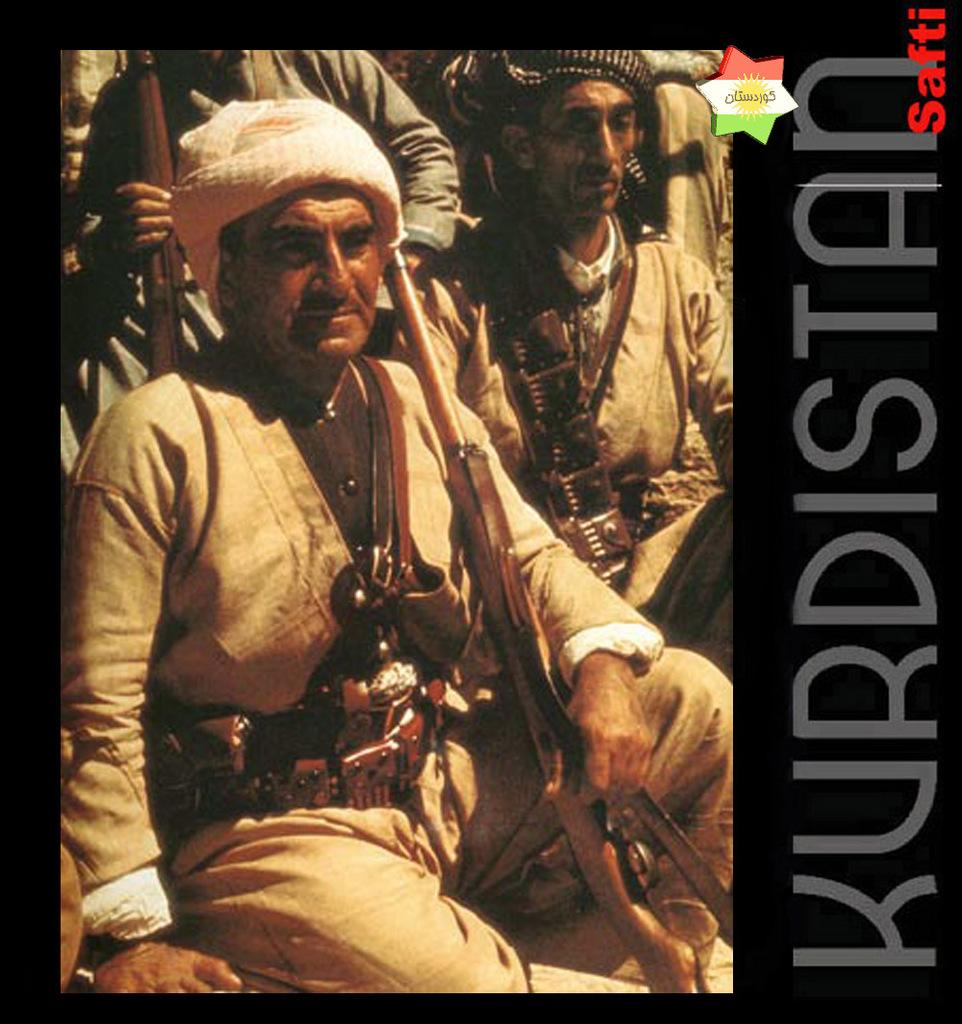What is the main subject of the poster in the image? The poster contains images of men holding guns. Are there any other elements on the poster besides the images? Yes, there is text on the poster. How many slaves are depicted on the poster? There are no slaves depicted on the poster; it features images of men holding guns. What type of wound is shown being treated on the poster? There is no wound present on the poster; it contains images of men holding guns and text. 